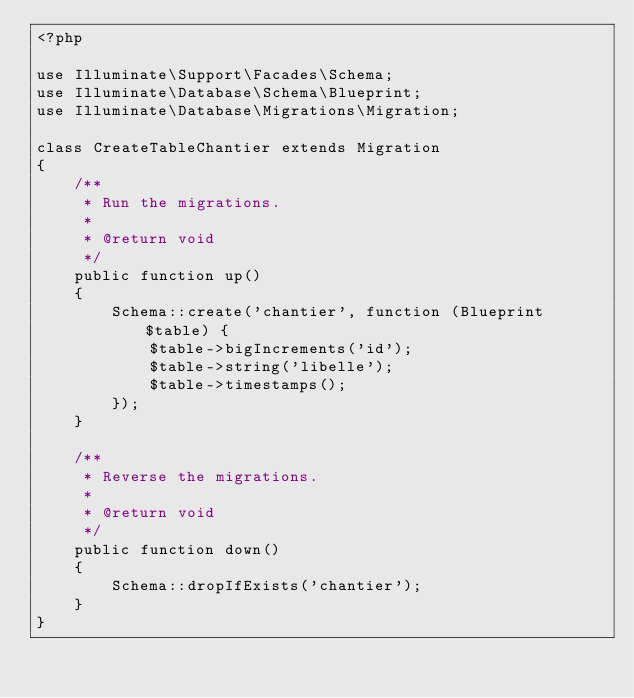Convert code to text. <code><loc_0><loc_0><loc_500><loc_500><_PHP_><?php

use Illuminate\Support\Facades\Schema;
use Illuminate\Database\Schema\Blueprint;
use Illuminate\Database\Migrations\Migration;

class CreateTableChantier extends Migration
{
    /**
     * Run the migrations.
     *
     * @return void
     */
    public function up()
    {
        Schema::create('chantier', function (Blueprint $table) {
            $table->bigIncrements('id');
            $table->string('libelle');
            $table->timestamps();
        });
    }

    /**
     * Reverse the migrations.
     *
     * @return void
     */
    public function down()
    {
        Schema::dropIfExists('chantier');
    }
}
</code> 